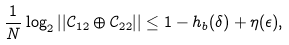Convert formula to latex. <formula><loc_0><loc_0><loc_500><loc_500>\frac { 1 } { N } \log _ { 2 } | | \mathcal { C } _ { 1 2 } \oplus \mathcal { C } _ { 2 2 } | | \leq 1 - h _ { b } ( \delta ) + \eta ( \epsilon ) ,</formula> 